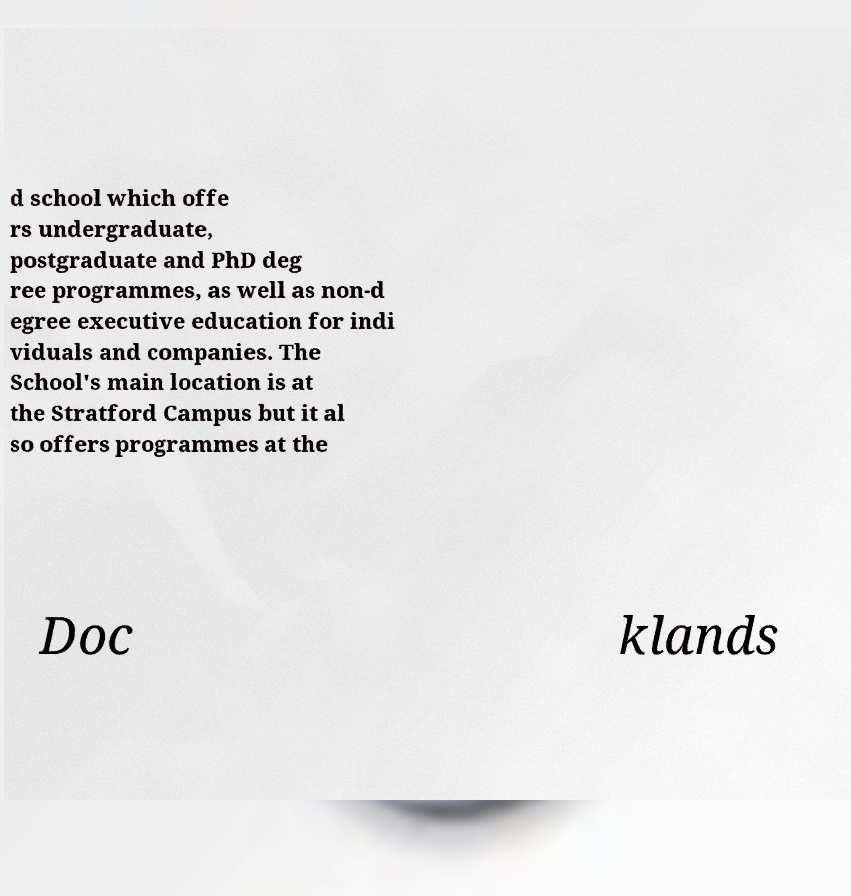For documentation purposes, I need the text within this image transcribed. Could you provide that? d school which offe rs undergraduate, postgraduate and PhD deg ree programmes, as well as non-d egree executive education for indi viduals and companies. The School's main location is at the Stratford Campus but it al so offers programmes at the Doc klands 